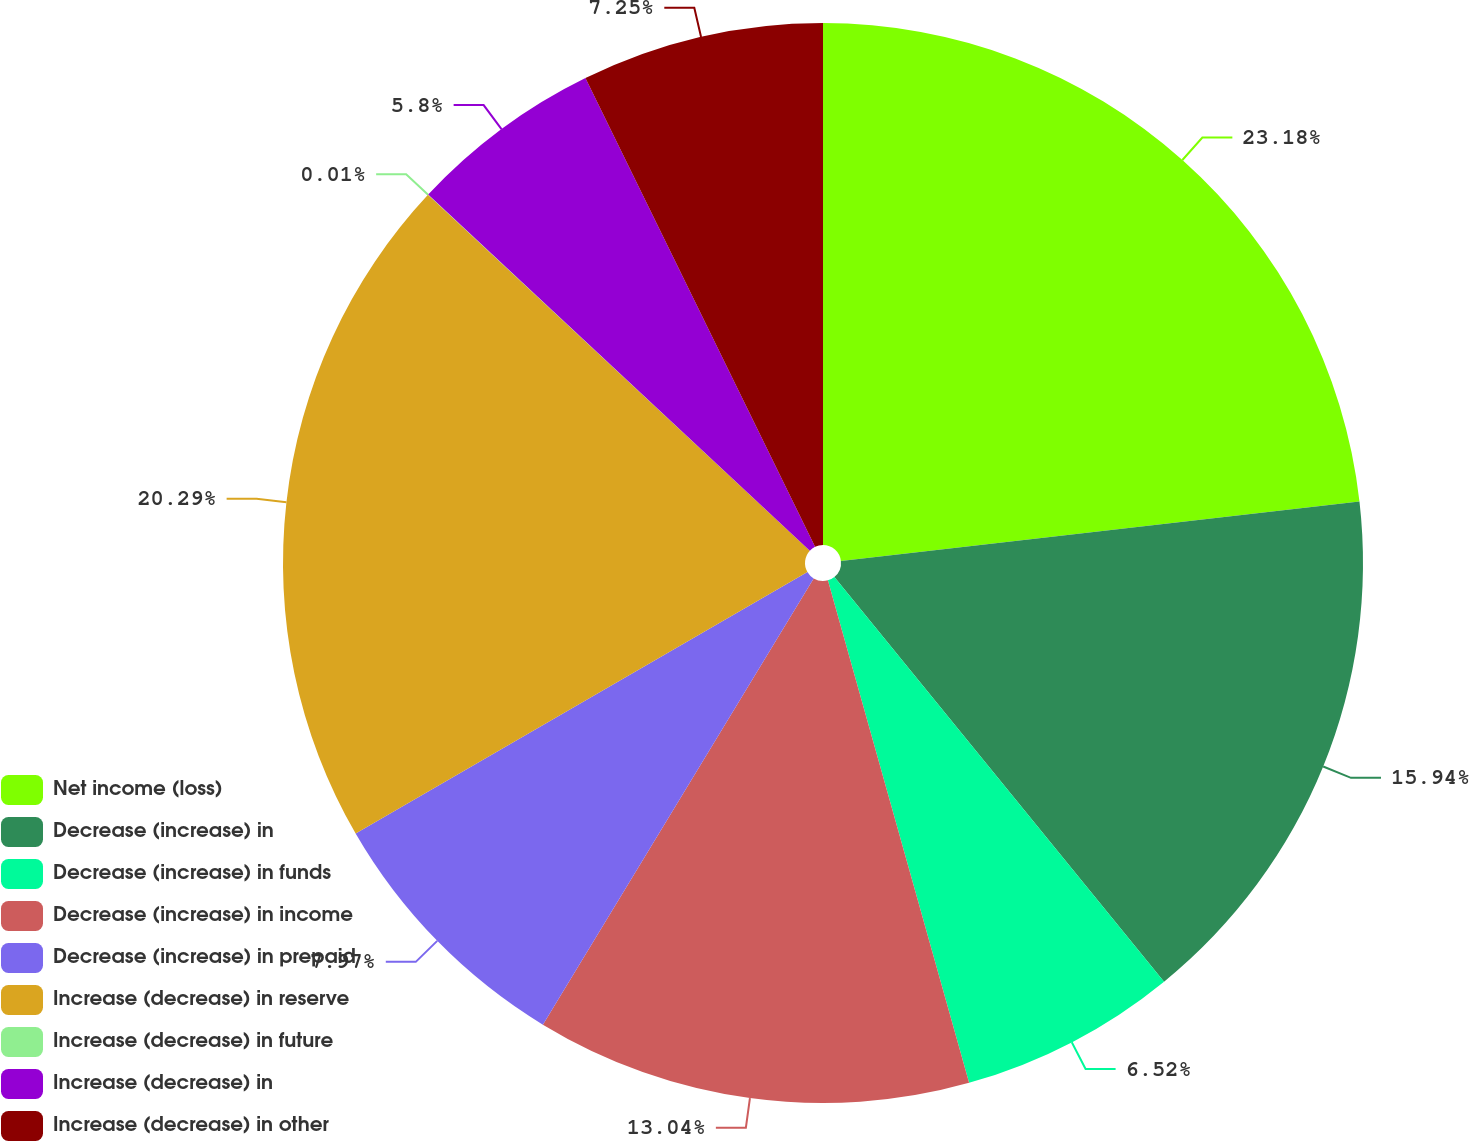<chart> <loc_0><loc_0><loc_500><loc_500><pie_chart><fcel>Net income (loss)<fcel>Decrease (increase) in<fcel>Decrease (increase) in funds<fcel>Decrease (increase) in income<fcel>Decrease (increase) in prepaid<fcel>Increase (decrease) in reserve<fcel>Increase (decrease) in future<fcel>Increase (decrease) in<fcel>Increase (decrease) in other<nl><fcel>23.18%<fcel>15.94%<fcel>6.52%<fcel>13.04%<fcel>7.97%<fcel>20.29%<fcel>0.01%<fcel>5.8%<fcel>7.25%<nl></chart> 